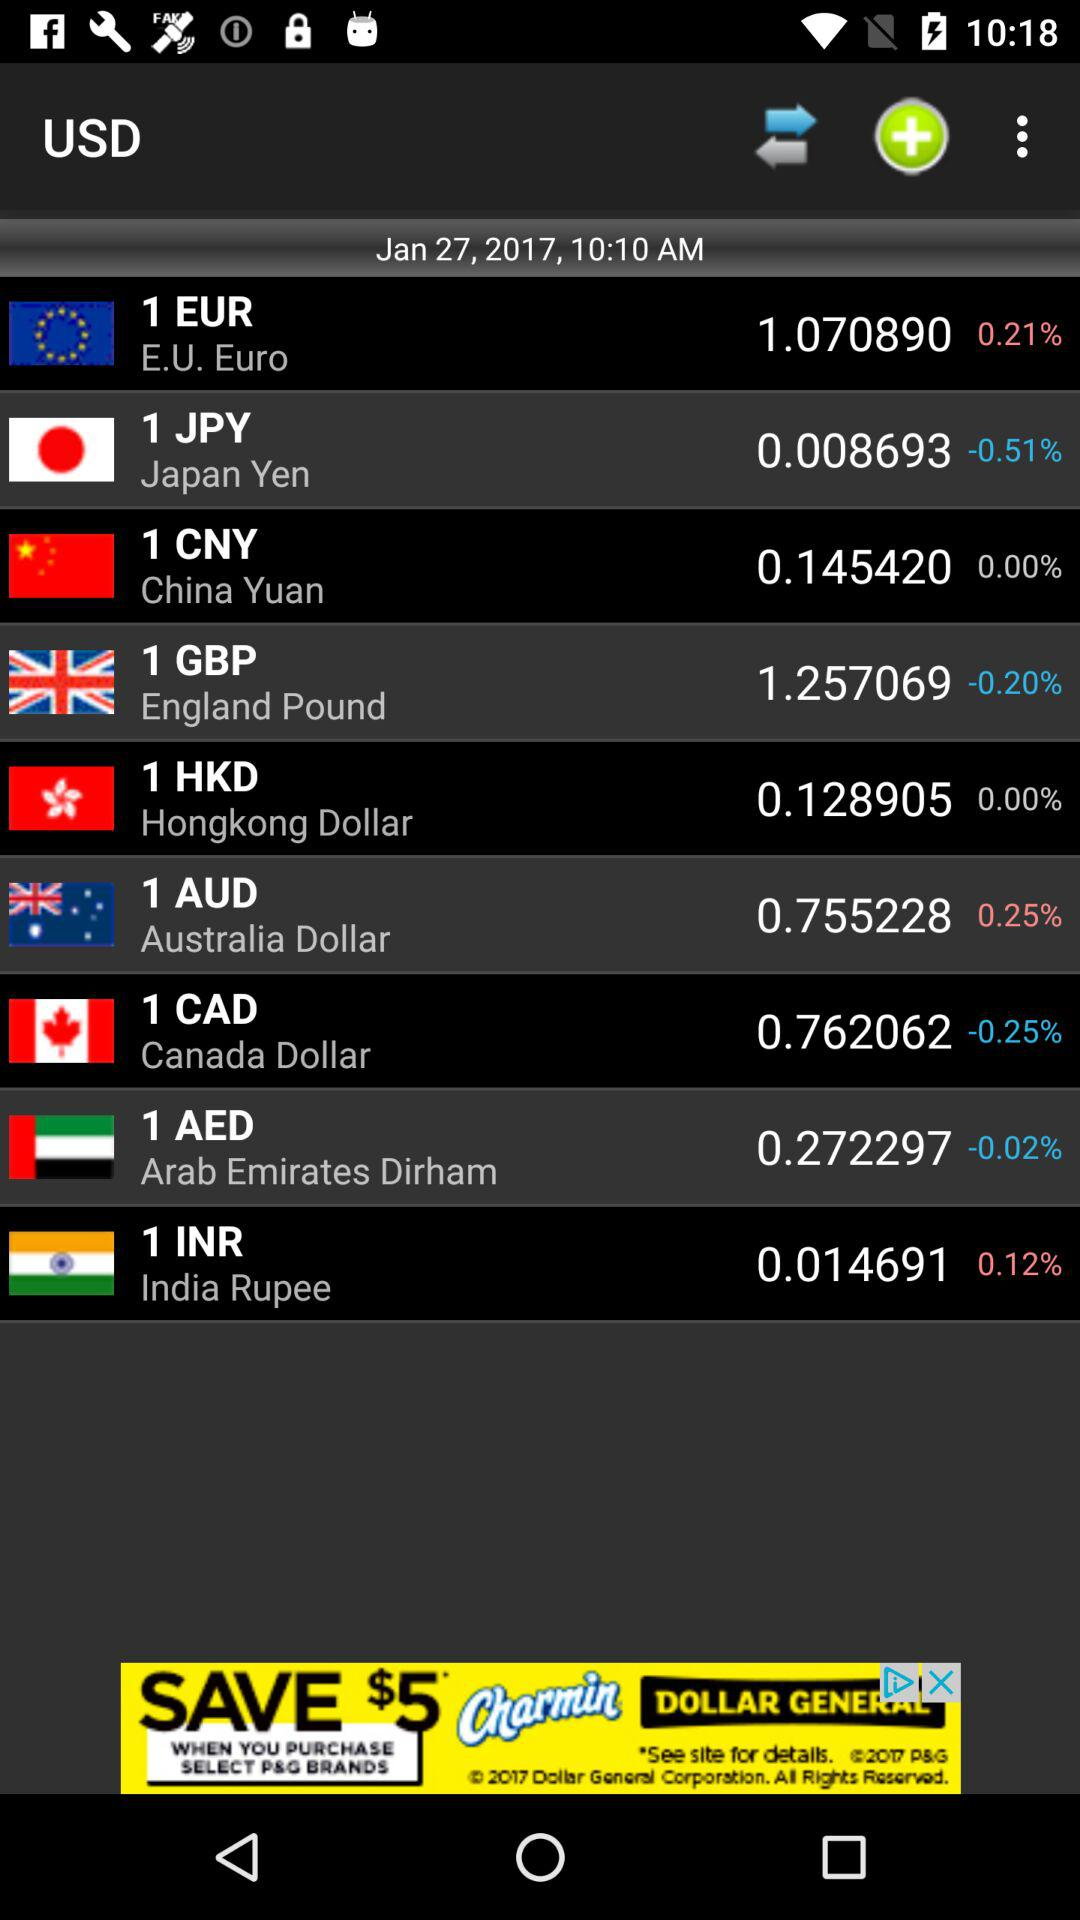What is the percentage change in the EUR since the last update?
Answer the question using a single word or phrase. 0.21% 